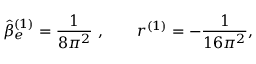<formula> <loc_0><loc_0><loc_500><loc_500>\hat { \beta } _ { e } ^ { ( 1 ) } = \frac { 1 } 8 \pi ^ { 2 } } \ , \quad r ^ { ( 1 ) } = - \frac { 1 } 1 6 \pi ^ { 2 } } ,</formula> 